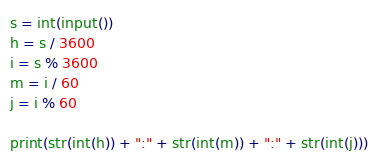Convert code to text. <code><loc_0><loc_0><loc_500><loc_500><_Python_>s = int(input())
h = s / 3600
i = s % 3600
m = i / 60
j = i % 60

print(str(int(h)) + ":" + str(int(m)) + ":" + str(int(j)))</code> 